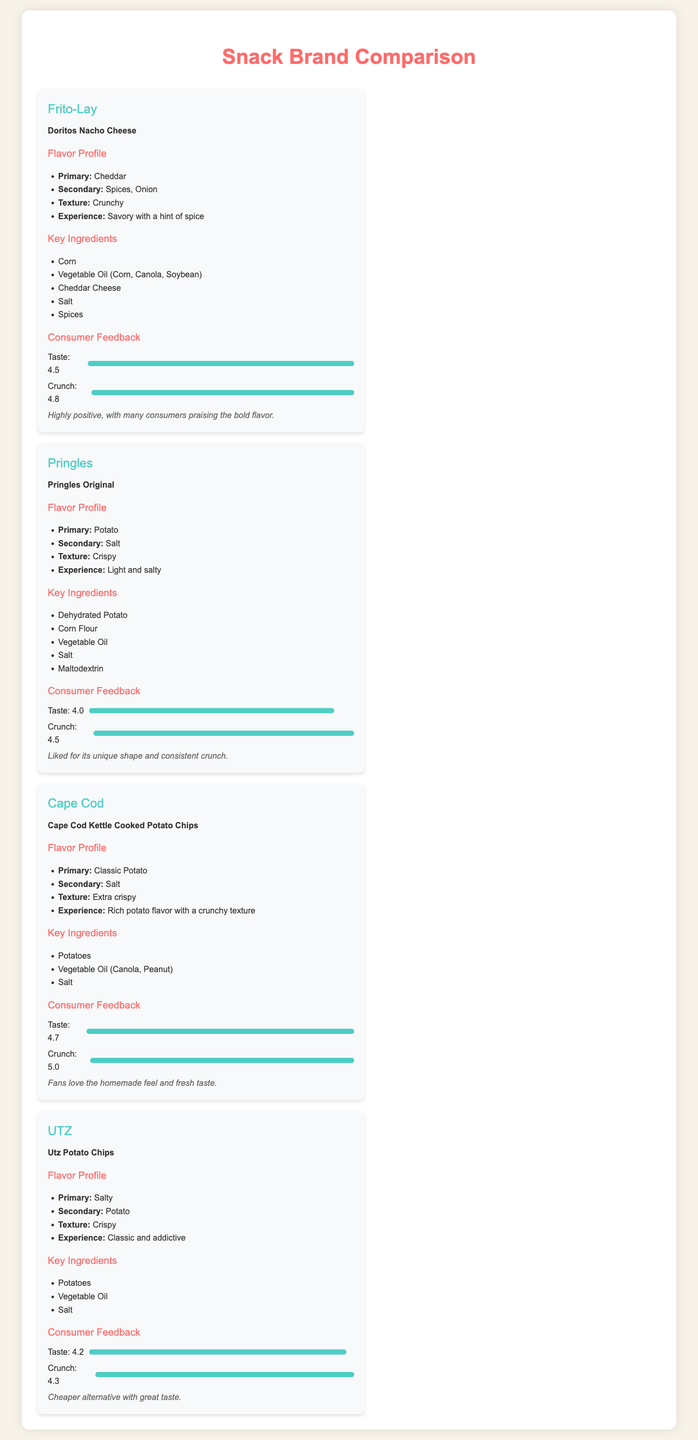What is the primary flavor of Doritos Nacho Cheese? The primary flavor of Doritos Nacho Cheese is cheddar as stated in the flavor profile section.
Answer: Cheddar What is the overall satisfaction rating for Cape Cod Kettle Cooked Potato Chips? The overall satisfaction for Cape Cod Kettle Cooked Potato Chips is described as "Fans love the homemade feel and fresh taste," which indicates a high satisfaction.
Answer: Highly positive Which brand has a taste rating of 4.5? The taste rating of 4.5 corresponds to both Doritos Nacho Cheese and Utz Potato Chips, showing they both have similar taste ratings.
Answer: Doritos Nacho Cheese, Utz Potato Chips What key ingredient is found in Pringles Original? One of the key ingredients listed for Pringles Original is dehydrated potato.
Answer: Dehydrated Potato Which snack has the highest crunch rating? The crunch rating for Cape Cod Kettle Cooked Potato Chips is the highest at 5.0, indicating it is considered the crunchiest.
Answer: 5.0 How many secondary flavors does Utz Potato Chips have? Utz Potato Chips features one secondary flavor listed, which is potato.
Answer: One What is the texture description for Pringles Original? The texture of Pringles Original is described as crispy in the document.
Answer: Crispy Which brand is noted for their "bold flavor"? The brand noted for their "bold flavor" is Frito-Lay in the description of Doritos Nacho Cheese.
Answer: Frito-Lay 